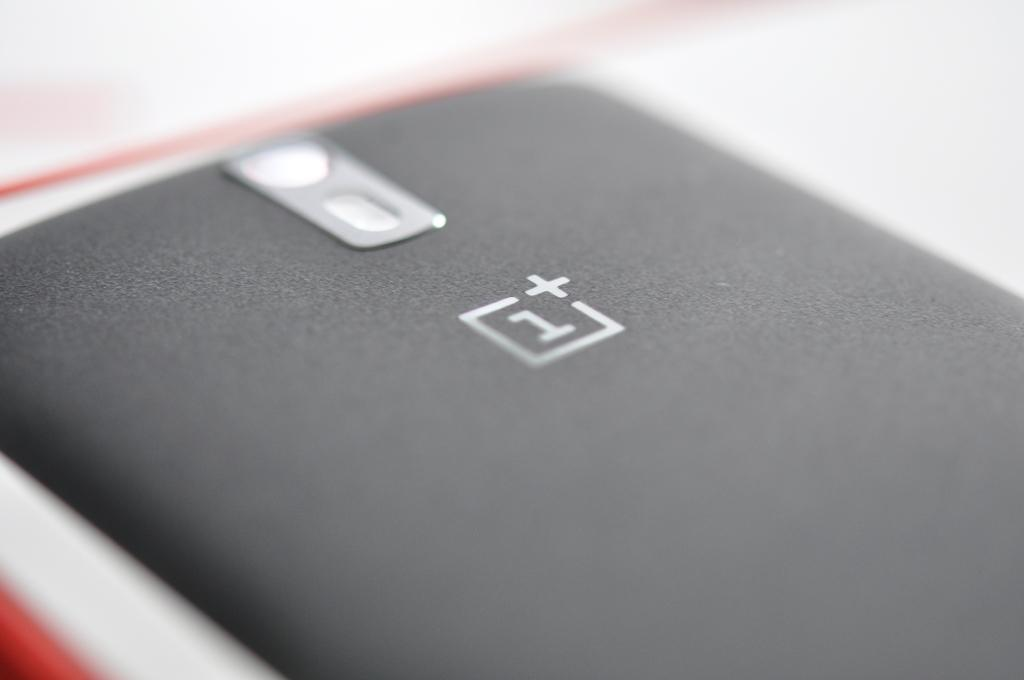<image>
Share a concise interpretation of the image provided. A smart phone lying upside down with the number 1 on the back of it. 